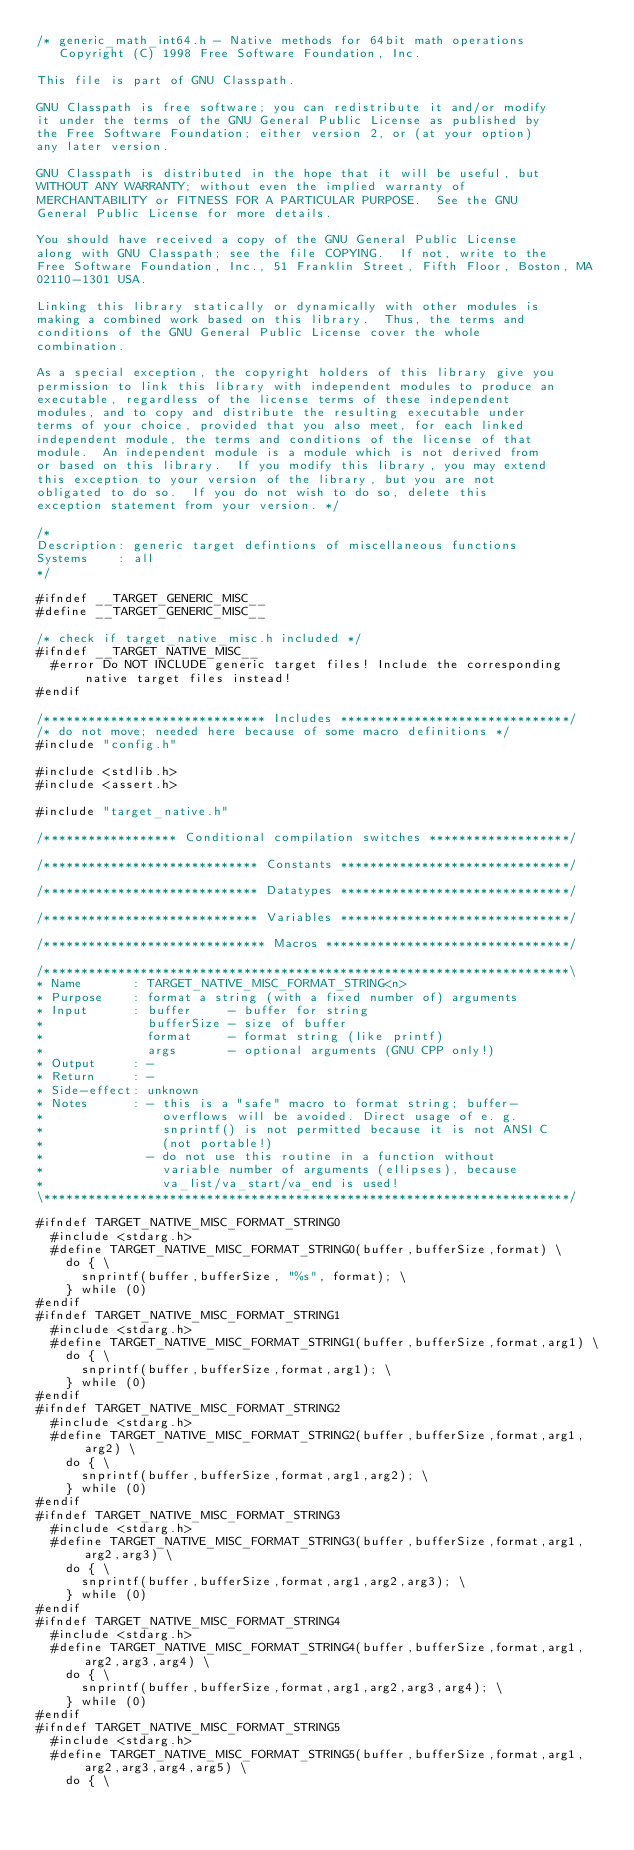<code> <loc_0><loc_0><loc_500><loc_500><_C_>/* generic_math_int64.h - Native methods for 64bit math operations
   Copyright (C) 1998 Free Software Foundation, Inc.

This file is part of GNU Classpath.

GNU Classpath is free software; you can redistribute it and/or modify
it under the terms of the GNU General Public License as published by
the Free Software Foundation; either version 2, or (at your option)
any later version.
 
GNU Classpath is distributed in the hope that it will be useful, but
WITHOUT ANY WARRANTY; without even the implied warranty of
MERCHANTABILITY or FITNESS FOR A PARTICULAR PURPOSE.  See the GNU
General Public License for more details.

You should have received a copy of the GNU General Public License
along with GNU Classpath; see the file COPYING.  If not, write to the
Free Software Foundation, Inc., 51 Franklin Street, Fifth Floor, Boston, MA
02110-1301 USA.

Linking this library statically or dynamically with other modules is
making a combined work based on this library.  Thus, the terms and
conditions of the GNU General Public License cover the whole
combination.

As a special exception, the copyright holders of this library give you
permission to link this library with independent modules to produce an
executable, regardless of the license terms of these independent
modules, and to copy and distribute the resulting executable under
terms of your choice, provided that you also meet, for each linked
independent module, the terms and conditions of the license of that
module.  An independent module is a module which is not derived from
or based on this library.  If you modify this library, you may extend
this exception to your version of the library, but you are not
obligated to do so.  If you do not wish to do so, delete this
exception statement from your version. */

/*
Description: generic target defintions of miscellaneous functions
Systems    : all
*/

#ifndef __TARGET_GENERIC_MISC__
#define __TARGET_GENERIC_MISC__

/* check if target_native_misc.h included */
#ifndef __TARGET_NATIVE_MISC__
  #error Do NOT INCLUDE generic target files! Include the corresponding native target files instead!
#endif

/****************************** Includes *******************************/
/* do not move; needed here because of some macro definitions */
#include "config.h"

#include <stdlib.h>
#include <assert.h>

#include "target_native.h"

/****************** Conditional compilation switches *******************/

/***************************** Constants *******************************/

/***************************** Datatypes *******************************/

/***************************** Variables *******************************/

/****************************** Macros *********************************/

/***********************************************************************\
* Name       : TARGET_NATIVE_MISC_FORMAT_STRING<n>
* Purpose    : format a string (with a fixed number of) arguments
* Input      : buffer     - buffer for string
*              bufferSize - size of buffer
*              format     - format string (like printf)
*              args       - optional arguments (GNU CPP only!)
* Output     : -
* Return     : -
* Side-effect: unknown
* Notes      : - this is a "safe" macro to format string; buffer-
*                overflows will be avoided. Direct usage of e. g.
*                snprintf() is not permitted because it is not ANSI C
*                (not portable!)
*              - do not use this routine in a function without
*                variable number of arguments (ellipses), because
*                va_list/va_start/va_end is used!
\***********************************************************************/

#ifndef TARGET_NATIVE_MISC_FORMAT_STRING0
  #include <stdarg.h>
  #define TARGET_NATIVE_MISC_FORMAT_STRING0(buffer,bufferSize,format) \
    do { \
      snprintf(buffer,bufferSize, "%s", format); \
    } while (0)
#endif
#ifndef TARGET_NATIVE_MISC_FORMAT_STRING1
  #include <stdarg.h>
  #define TARGET_NATIVE_MISC_FORMAT_STRING1(buffer,bufferSize,format,arg1) \
    do { \
      snprintf(buffer,bufferSize,format,arg1); \
    } while (0)
#endif
#ifndef TARGET_NATIVE_MISC_FORMAT_STRING2
  #include <stdarg.h>
  #define TARGET_NATIVE_MISC_FORMAT_STRING2(buffer,bufferSize,format,arg1,arg2) \
    do { \
      snprintf(buffer,bufferSize,format,arg1,arg2); \
    } while (0)
#endif
#ifndef TARGET_NATIVE_MISC_FORMAT_STRING3
  #include <stdarg.h>
  #define TARGET_NATIVE_MISC_FORMAT_STRING3(buffer,bufferSize,format,arg1,arg2,arg3) \
    do { \
      snprintf(buffer,bufferSize,format,arg1,arg2,arg3); \
    } while (0)
#endif
#ifndef TARGET_NATIVE_MISC_FORMAT_STRING4
  #include <stdarg.h>
  #define TARGET_NATIVE_MISC_FORMAT_STRING4(buffer,bufferSize,format,arg1,arg2,arg3,arg4) \
    do { \
      snprintf(buffer,bufferSize,format,arg1,arg2,arg3,arg4); \
    } while (0)
#endif
#ifndef TARGET_NATIVE_MISC_FORMAT_STRING5
  #include <stdarg.h>
  #define TARGET_NATIVE_MISC_FORMAT_STRING5(buffer,bufferSize,format,arg1,arg2,arg3,arg4,arg5) \
    do { \</code> 